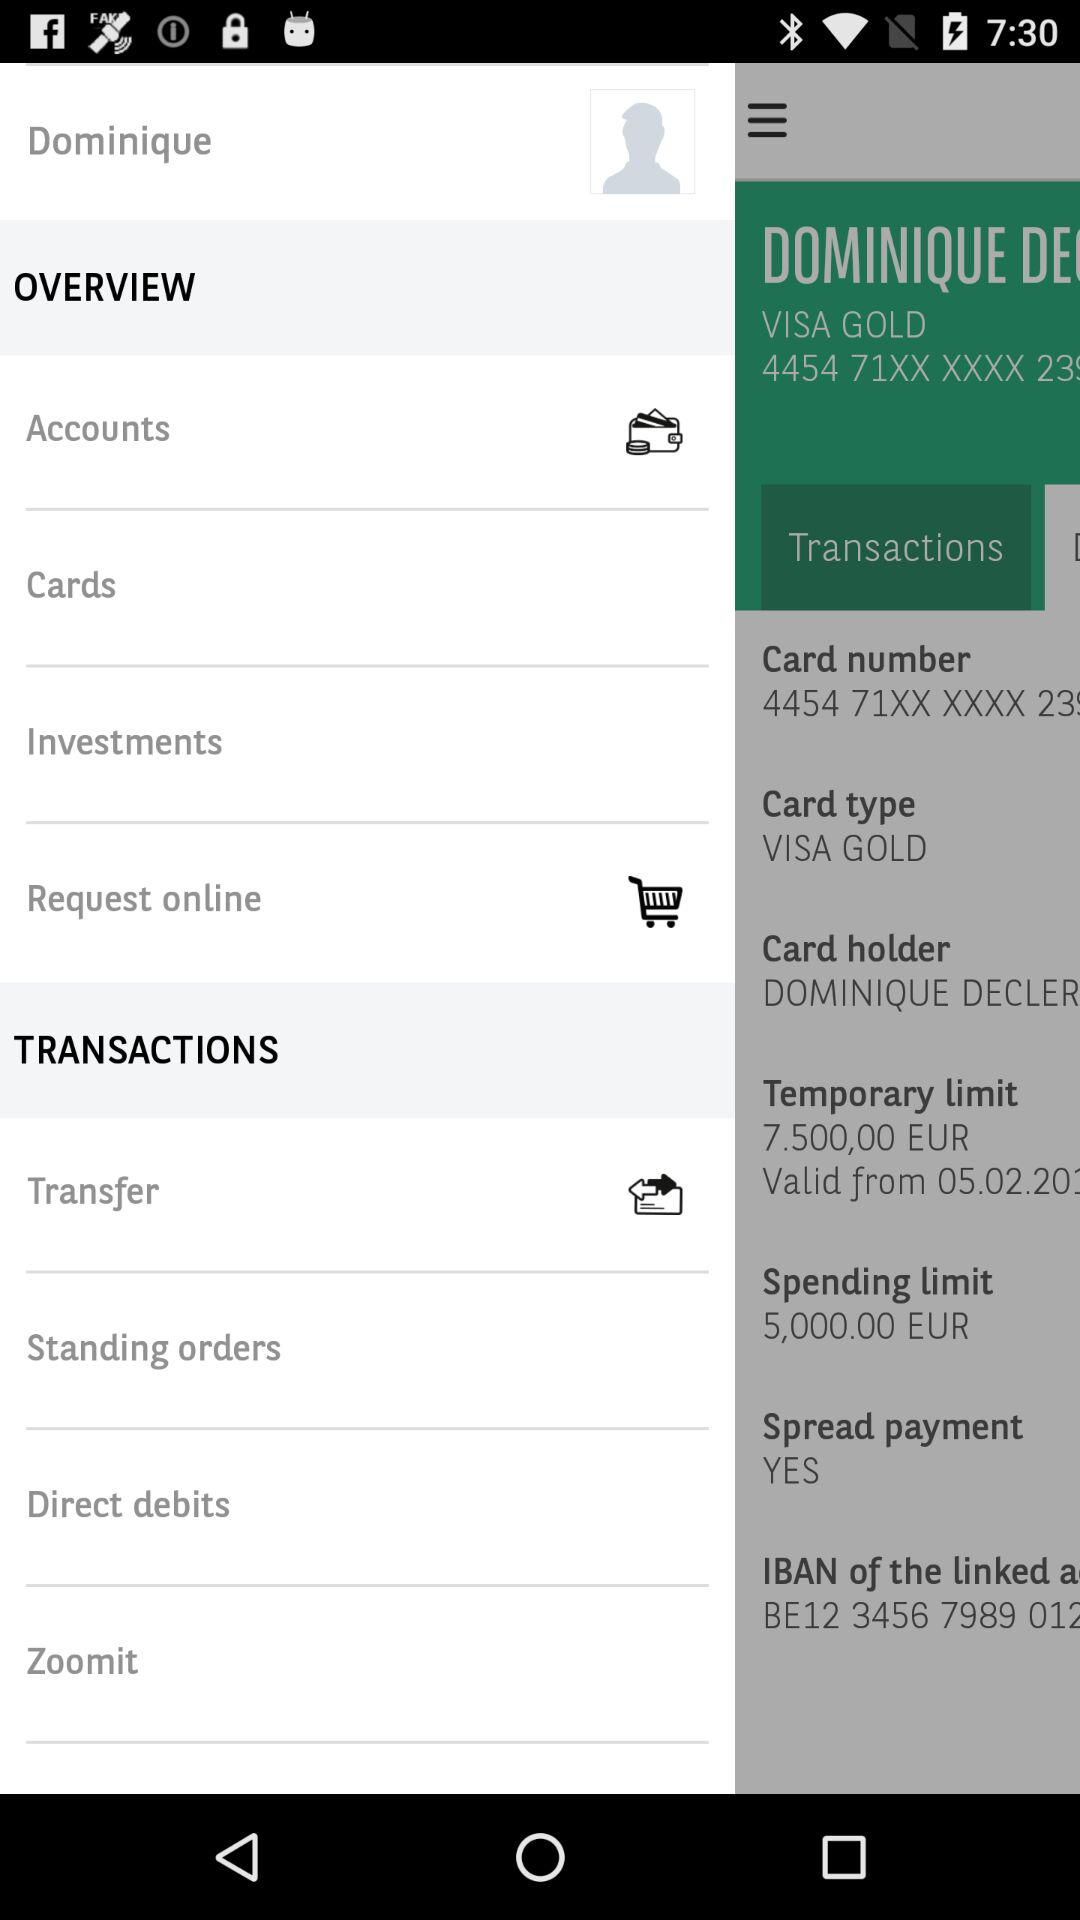What is the card type? The card type is VISA GOLD. 